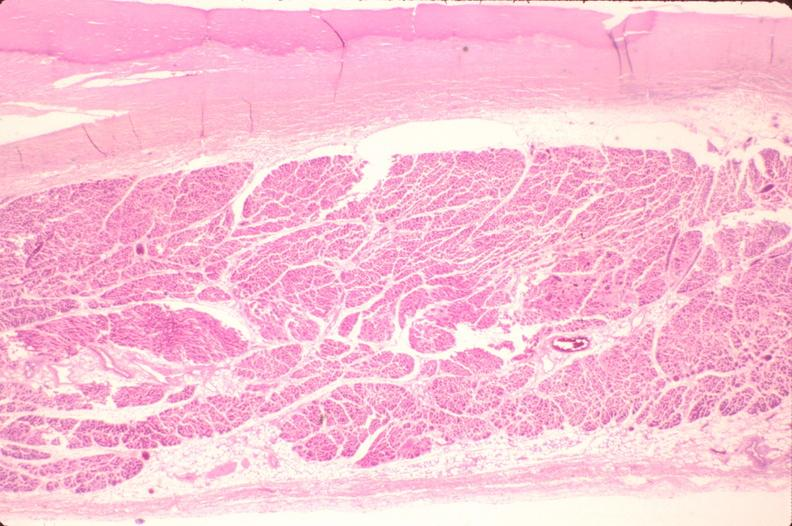s cardiovascular present?
Answer the question using a single word or phrase. Yes 